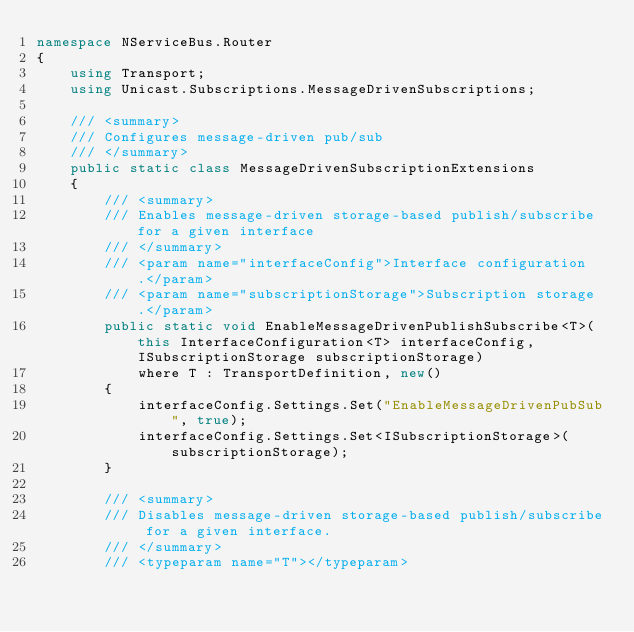Convert code to text. <code><loc_0><loc_0><loc_500><loc_500><_C#_>namespace NServiceBus.Router
{
    using Transport;
    using Unicast.Subscriptions.MessageDrivenSubscriptions;

    /// <summary>
    /// Configures message-driven pub/sub
    /// </summary>
    public static class MessageDrivenSubscriptionExtensions
    {
        /// <summary>
        /// Enables message-driven storage-based publish/subscribe for a given interface
        /// </summary>
        /// <param name="interfaceConfig">Interface configuration.</param>
        /// <param name="subscriptionStorage">Subscription storage.</param>
        public static void EnableMessageDrivenPublishSubscribe<T>(this InterfaceConfiguration<T> interfaceConfig, ISubscriptionStorage subscriptionStorage)
            where T : TransportDefinition, new()
        {
            interfaceConfig.Settings.Set("EnableMessageDrivenPubSub", true);
            interfaceConfig.Settings.Set<ISubscriptionStorage>(subscriptionStorage);
        }

        /// <summary>
        /// Disables message-driven storage-based publish/subscribe for a given interface. 
        /// </summary>
        /// <typeparam name="T"></typeparam></code> 